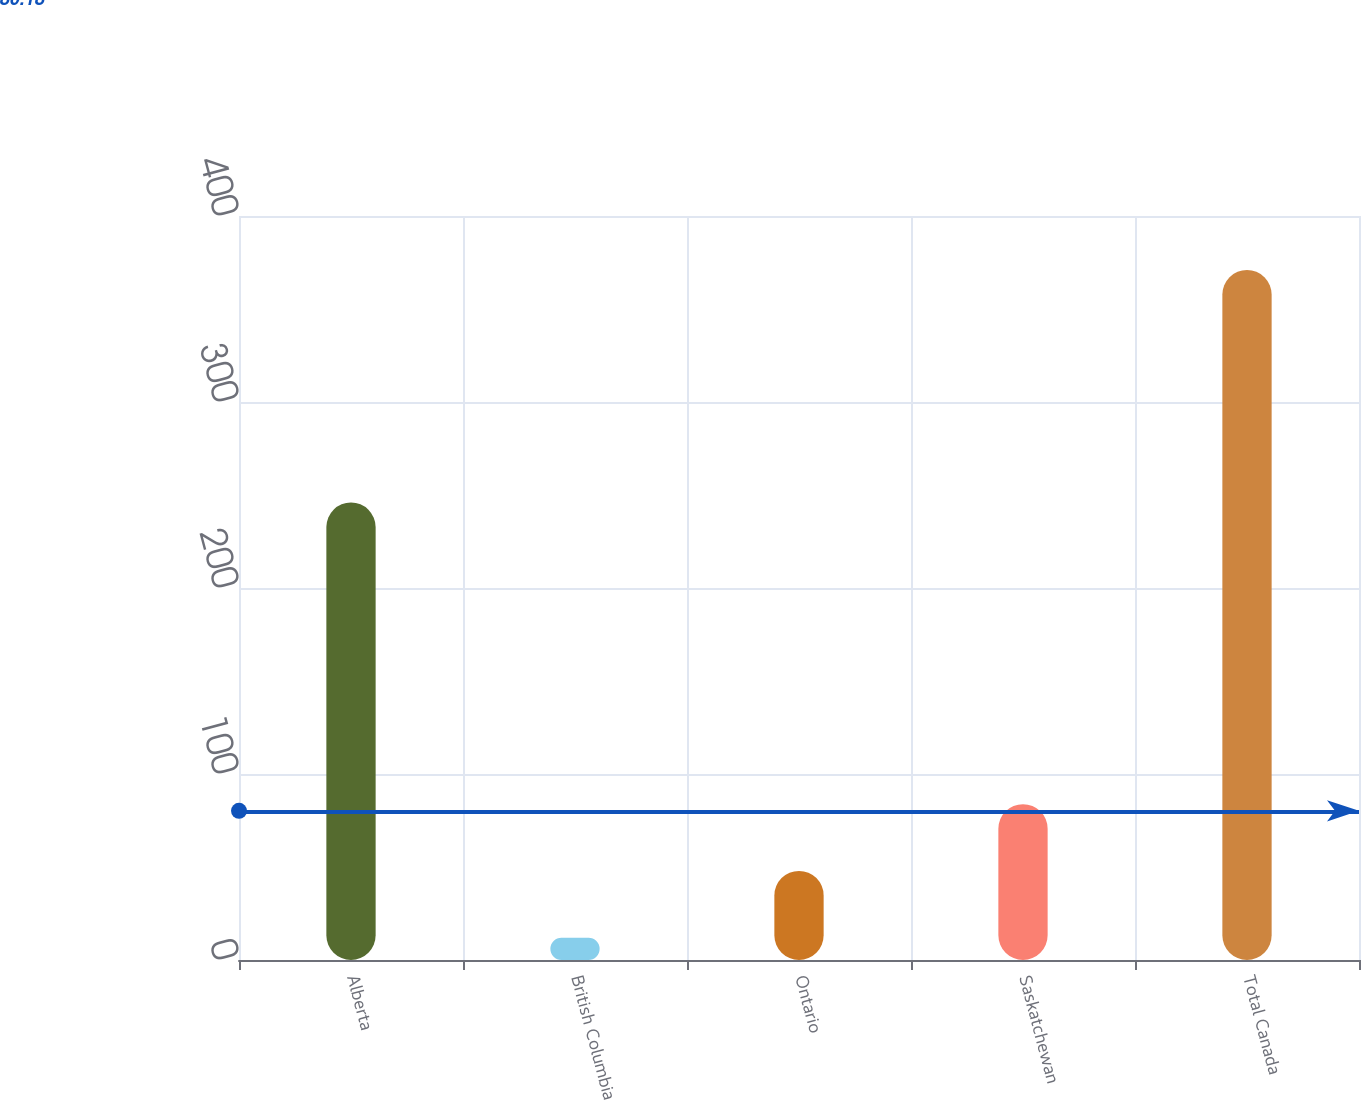<chart> <loc_0><loc_0><loc_500><loc_500><bar_chart><fcel>Alberta<fcel>British Columbia<fcel>Ontario<fcel>Saskatchewan<fcel>Total Canada<nl><fcel>246<fcel>12<fcel>47.9<fcel>83.8<fcel>371<nl></chart> 